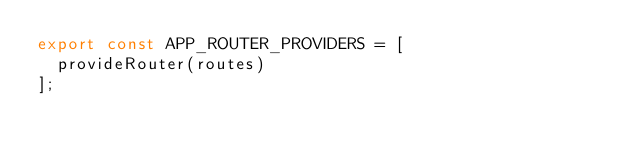<code> <loc_0><loc_0><loc_500><loc_500><_TypeScript_>export const APP_ROUTER_PROVIDERS = [
  provideRouter(routes)
];
</code> 